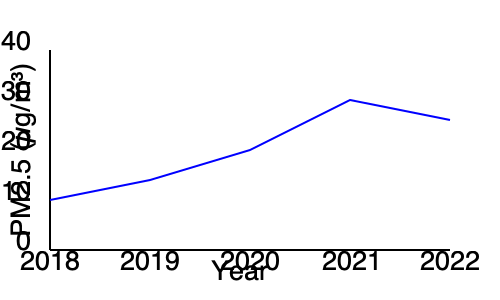Based on the air quality trend shown in the line graph, which year had the lowest PM2.5 concentration, and what potential factor could explain this improvement? To answer this question, we need to follow these steps:

1. Examine the graph to identify the lowest point on the line, which represents the lowest PM2.5 concentration.
2. The lowest point occurs in 2021, indicating the best air quality during the period shown.
3. Consider potential factors that could explain this improvement:
   a) The graph shows a consistent decrease from 2018 to 2021, suggesting ongoing efforts to reduce air pollution.
   b) 2020-2021 coincides with the global COVID-19 pandemic, which led to reduced industrial activities and vehicle traffic in many areas.
   c) As a zoning board member, we should consider if any new regulations or zoning changes were implemented during this period that could have contributed to the improvement.
4. The slight increase in 2022 might indicate a partial return to pre-pandemic activities, but levels remain lower than pre-2020, suggesting some lasting improvements.

Given the persona of a zoning board member, it's important to note that while external factors like the pandemic likely played a role, local zoning and environmental policies could also have contributed to this improvement. The challenge now would be to maintain these lower levels as normal activities resume.
Answer: 2021; likely due to reduced activities during the COVID-19 pandemic and potential local environmental policies. 